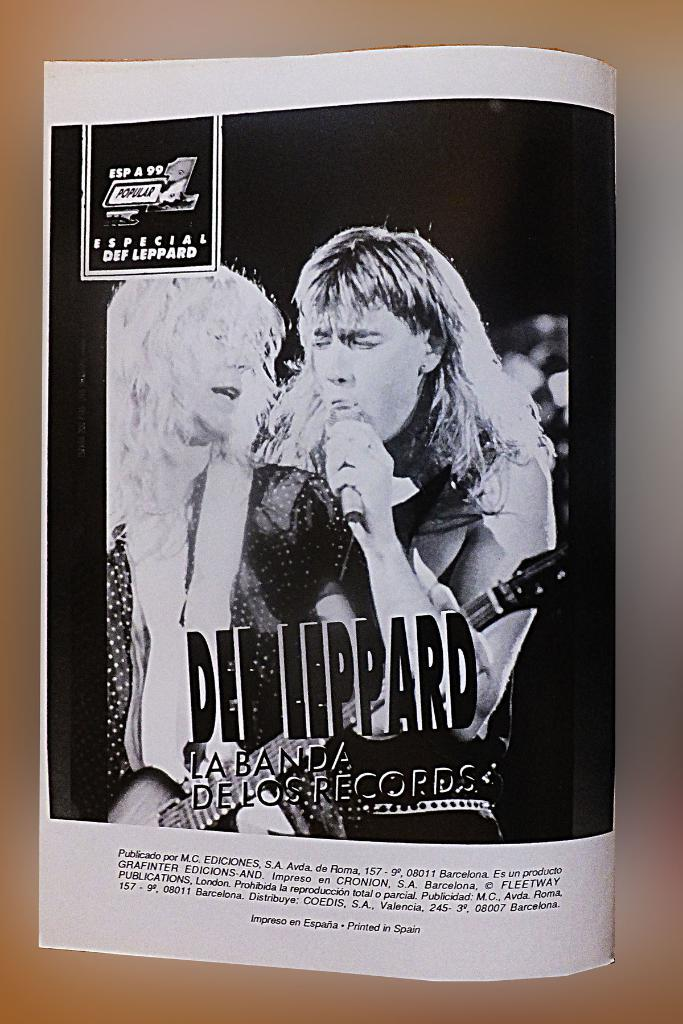<image>
Present a compact description of the photo's key features. A black and white page from a magazine advertising Def Leppard. 